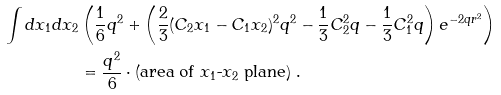Convert formula to latex. <formula><loc_0><loc_0><loc_500><loc_500>\int d x _ { 1 } d x _ { 2 } & \left ( \frac { 1 } { 6 } q ^ { 2 } + \left ( \frac { 2 } { 3 } ( C _ { 2 } x _ { 1 } - C _ { 1 } x _ { 2 } ) ^ { 2 } q ^ { 2 } - \frac { 1 } { 3 } C _ { 2 } ^ { 2 } q - \frac { 1 } { 3 } C _ { 1 } ^ { 2 } q \right ) e ^ { - 2 q r ^ { 2 } } \right ) \\ & = \frac { q ^ { 2 } } { 6 } \cdot \text {(area of $x_{1}$-$x_{2}$ plane)} \ .</formula> 